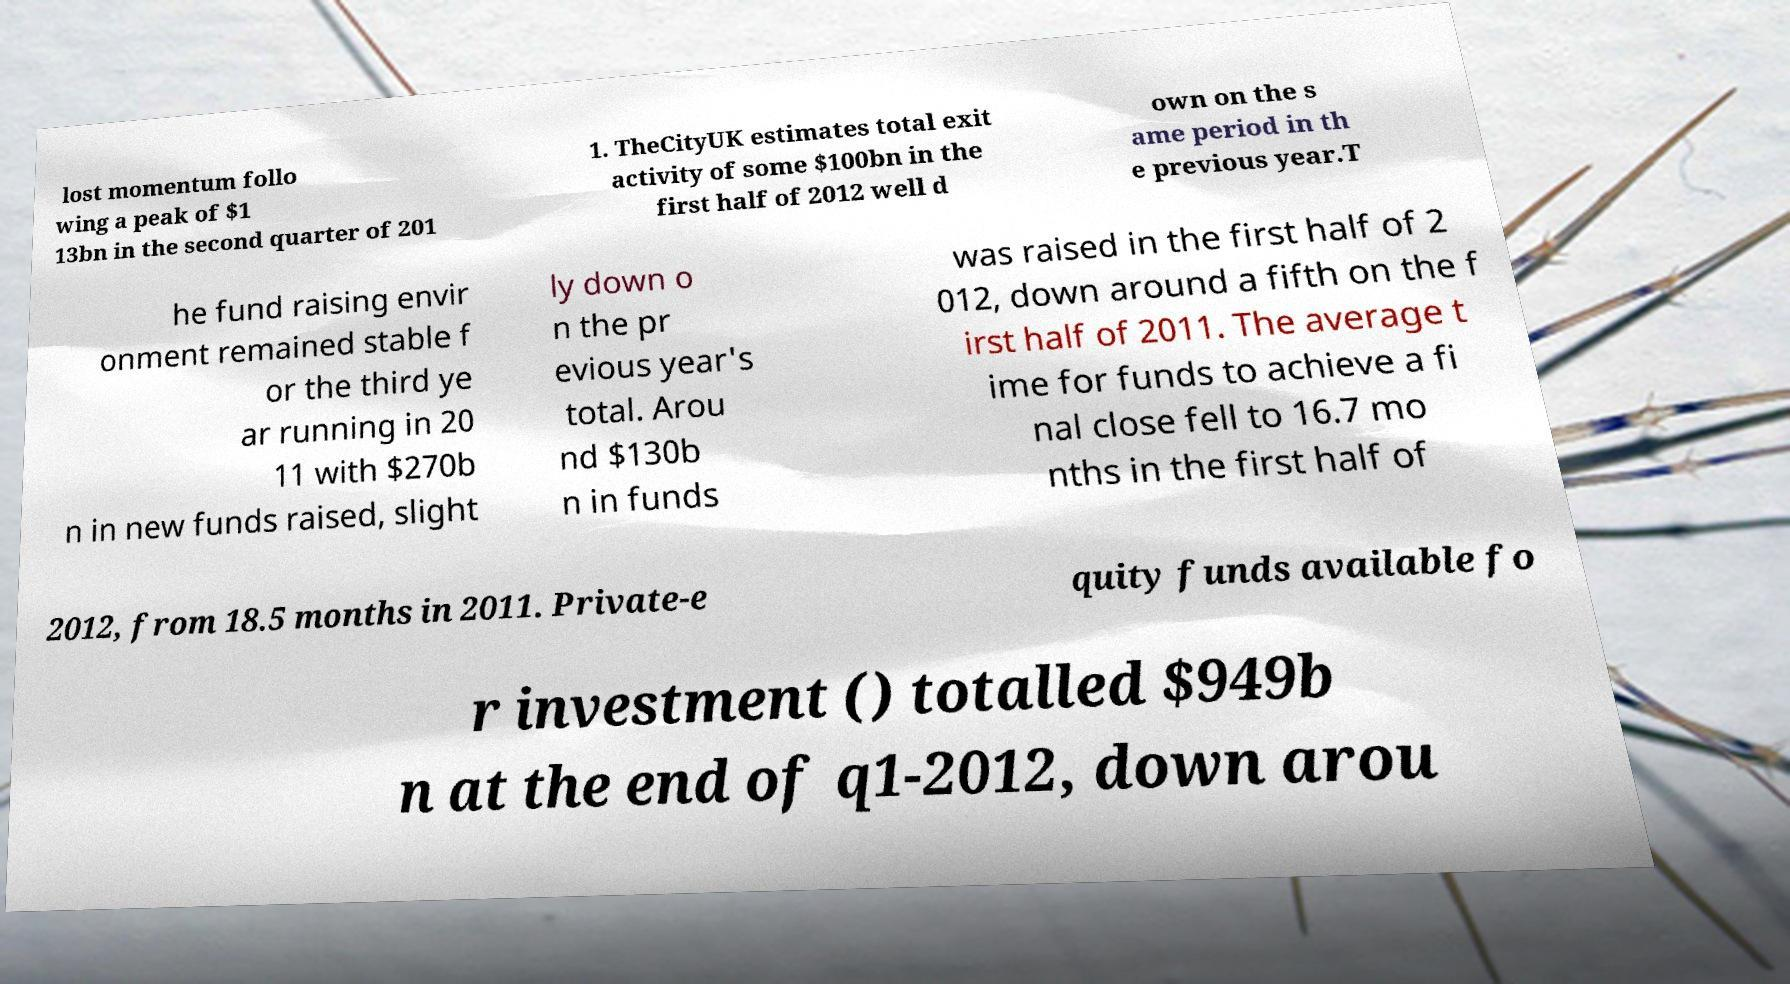What messages or text are displayed in this image? I need them in a readable, typed format. lost momentum follo wing a peak of $1 13bn in the second quarter of 201 1. TheCityUK estimates total exit activity of some $100bn in the first half of 2012 well d own on the s ame period in th e previous year.T he fund raising envir onment remained stable f or the third ye ar running in 20 11 with $270b n in new funds raised, slight ly down o n the pr evious year's total. Arou nd $130b n in funds was raised in the first half of 2 012, down around a fifth on the f irst half of 2011. The average t ime for funds to achieve a fi nal close fell to 16.7 mo nths in the first half of 2012, from 18.5 months in 2011. Private-e quity funds available fo r investment () totalled $949b n at the end of q1-2012, down arou 